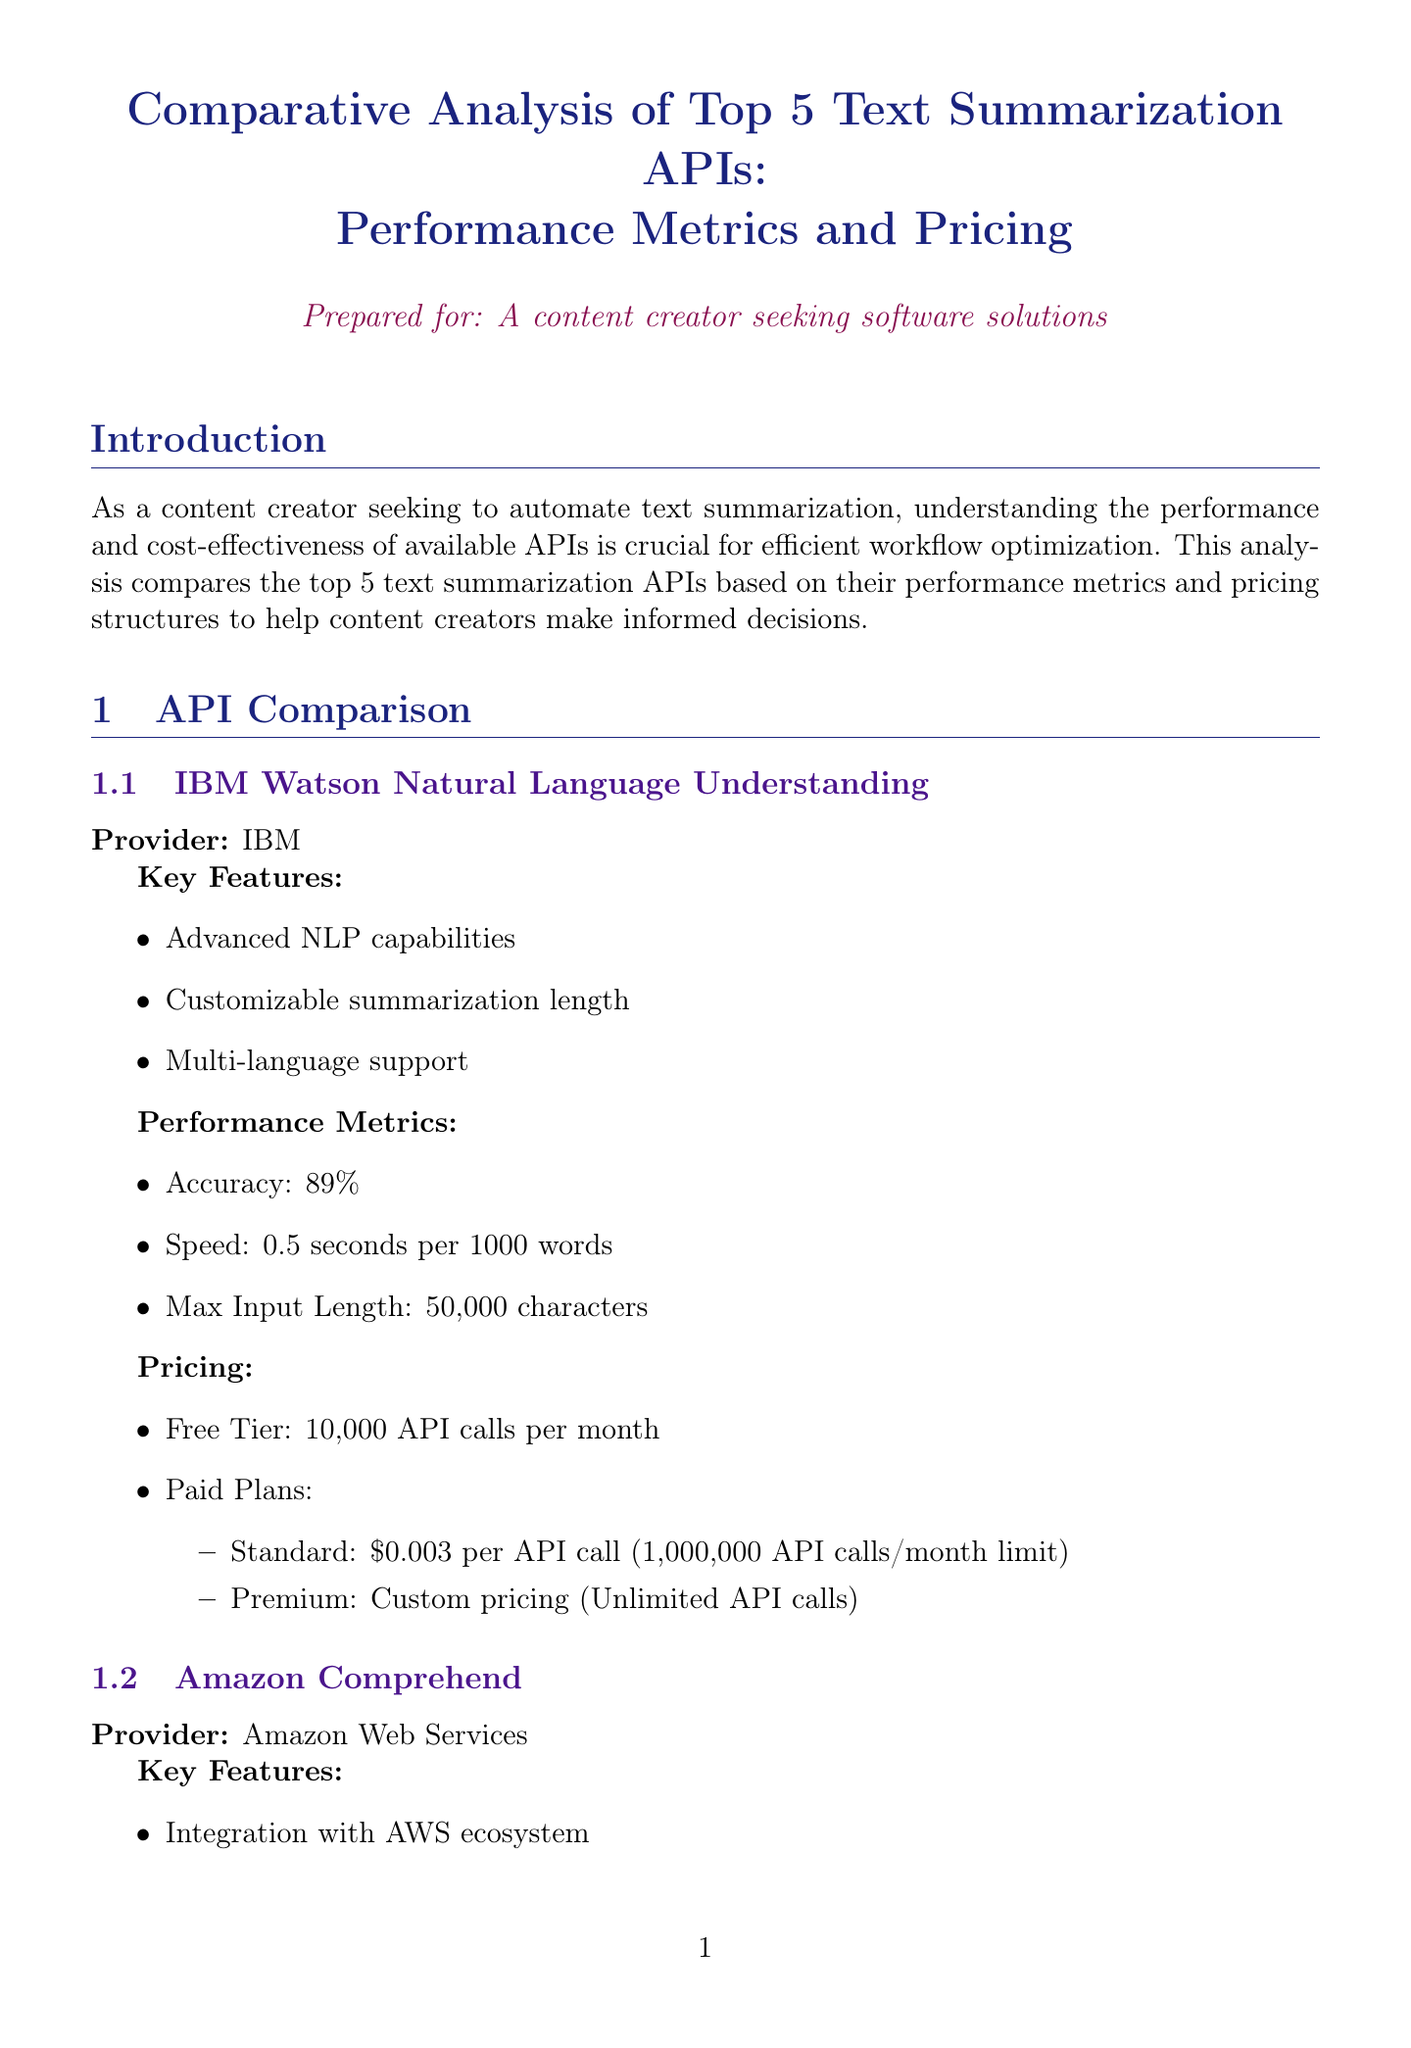What is the accuracy of Google Cloud Natural Language API? The accuracy of Google Cloud Natural Language API is provided in the performance metrics section of the document.
Answer: 92% How many API calls does the free tier of IBM Watson offer? The free tier offerings for IBM Watson are explicitly listed in the pricing section of the document.
Answer: 10,000 API calls per month What is the maximum input length for Microsoft Azure Text Analytics? The maximum input length is mentioned under the performance metrics for Microsoft Azure Text Analytics.
Answer: 125,000 characters Which API has the fastest processing speed? A comparison of speeds across all APIs is provided, allowing us to determine which one is the fastest.
Answer: Google Cloud Natural Language API For which specific type of content is Aylien Text Analysis API specialized? The key features of Aylien Text Analysis API indicate its specialization in a particular area.
Answer: News and article summarization What is the price of the standard plan for IBM Watson? The pricing details for paid plans for IBM Watson include specific prices for each plan that can be retrieved from the document.
Answer: $0.003 per API call Which API provides integration with the AWS ecosystem? The specific capabilities of different APIs, including integration features, are described in the key features sections.
Answer: Amazon Comprehend What is the recommendation for high-volume summarization? The conclusion section provides recommendations based on varying requirements, including high-volume summarization.
Answer: Google Cloud or Amazon Comprehend 